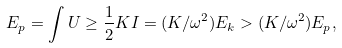<formula> <loc_0><loc_0><loc_500><loc_500>E _ { p } = \int U \geq \frac { 1 } { 2 } K I = ( K / \omega ^ { 2 } ) E _ { k } > ( K / \omega ^ { 2 } ) E _ { p } ,</formula> 